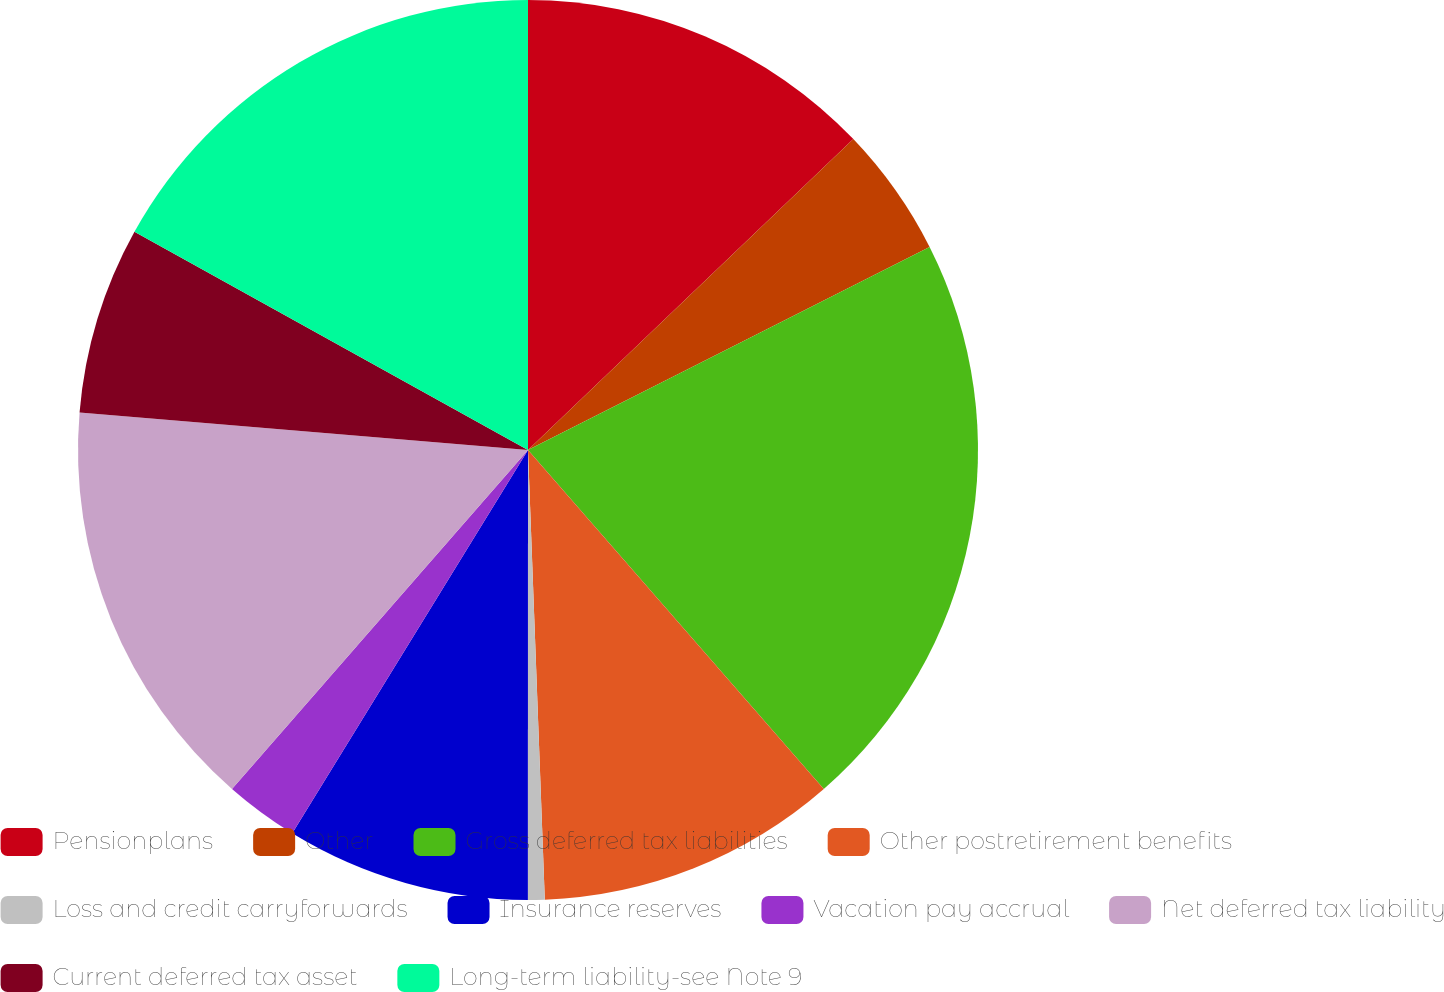<chart> <loc_0><loc_0><loc_500><loc_500><pie_chart><fcel>Pensionplans<fcel>Other<fcel>Gross deferred tax liabilities<fcel>Other postretirement benefits<fcel>Loss and credit carryforwards<fcel>Insurance reserves<fcel>Vacation pay accrual<fcel>Net deferred tax liability<fcel>Current deferred tax asset<fcel>Long-term liability-see Note 9<nl><fcel>12.86%<fcel>4.69%<fcel>21.03%<fcel>10.82%<fcel>0.6%<fcel>8.77%<fcel>2.65%<fcel>14.9%<fcel>6.73%<fcel>16.94%<nl></chart> 